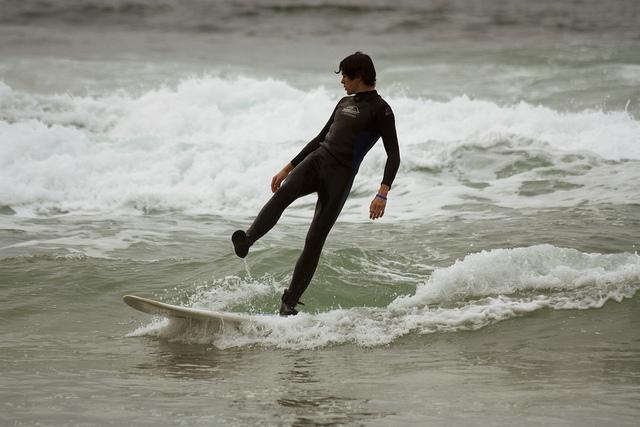Is the kid coming in from a ride on a surfboard?
Write a very short answer. Yes. How many feet are touching the board?
Concise answer only. 1. Is the man falling?
Be succinct. No. Is the water waist deep?
Short answer required. Yes. What stance is the surfer in?
Be succinct. Standing. 